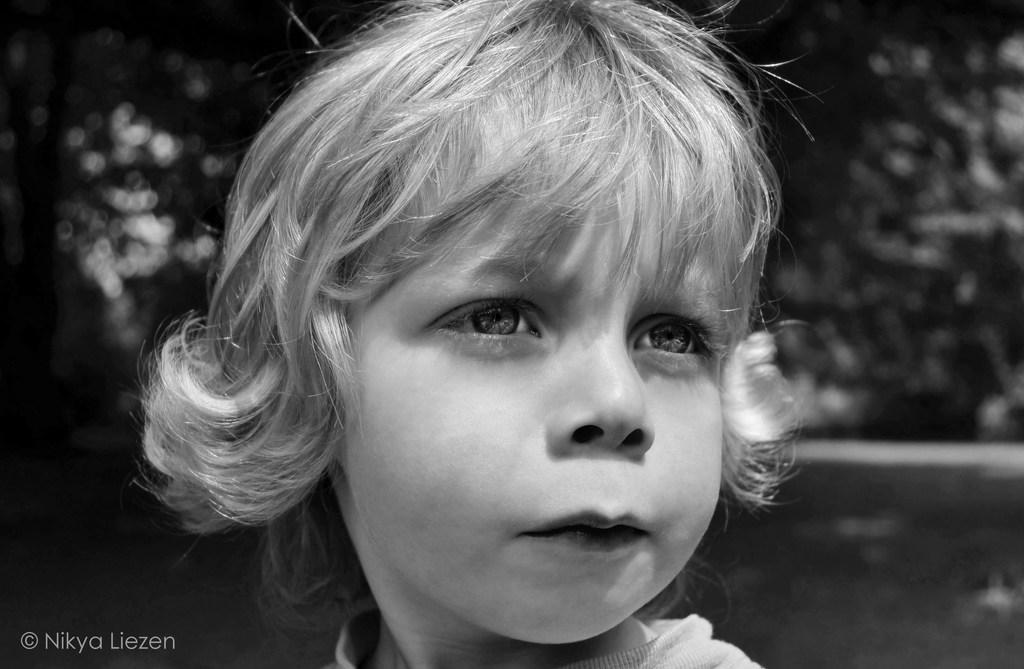What is the color scheme of the image? The image is black and white. Can you describe the main subject in the image? There is a person in the image. What can be observed about the background of the image? The background of the image is blurred. Where is the text located in the image? The text is in the bottom left corner of the image. What type of farmer is shown working in the image? There is no farmer present in the image; it features a person with a blurred background and text in the bottom left corner. How many plates are visible on the table in the image? There is no table or plates present in the image. 